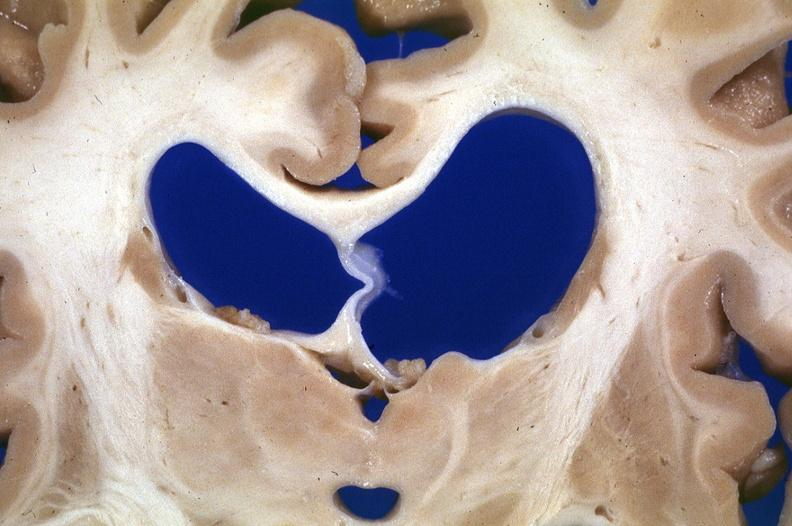what is present?
Answer the question using a single word or phrase. Nervous 